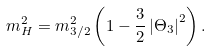<formula> <loc_0><loc_0><loc_500><loc_500>m ^ { 2 } _ { H } = m ^ { 2 } _ { 3 / 2 } \left ( 1 - \frac { 3 } { 2 } \left | \Theta _ { 3 } \right | ^ { 2 } \right ) .</formula> 